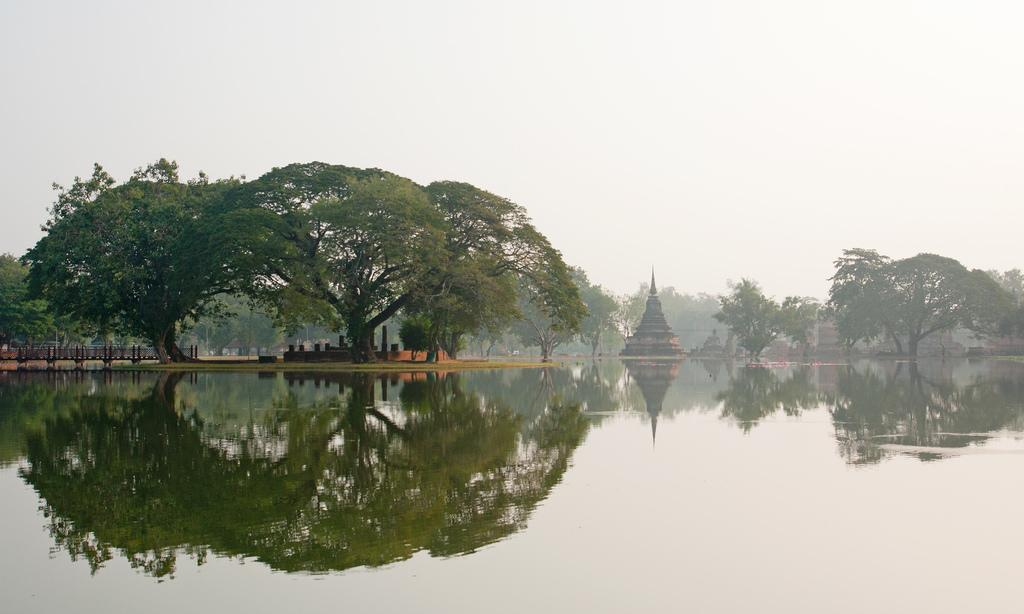What type of natural elements can be seen in the image? There are trees in the image. What type of man-made structures are present in the image? There are architectures in the image. What is visible in the background of the image? The sky is visible behind the trees. What type of water body can be seen in the image? There appears to be a lake in front of the trees. How many legs does the rat have in the image? There is no rat present in the image. What type of flesh can be seen hanging from the trees in the image? There is no flesh hanging from the trees in the image. 